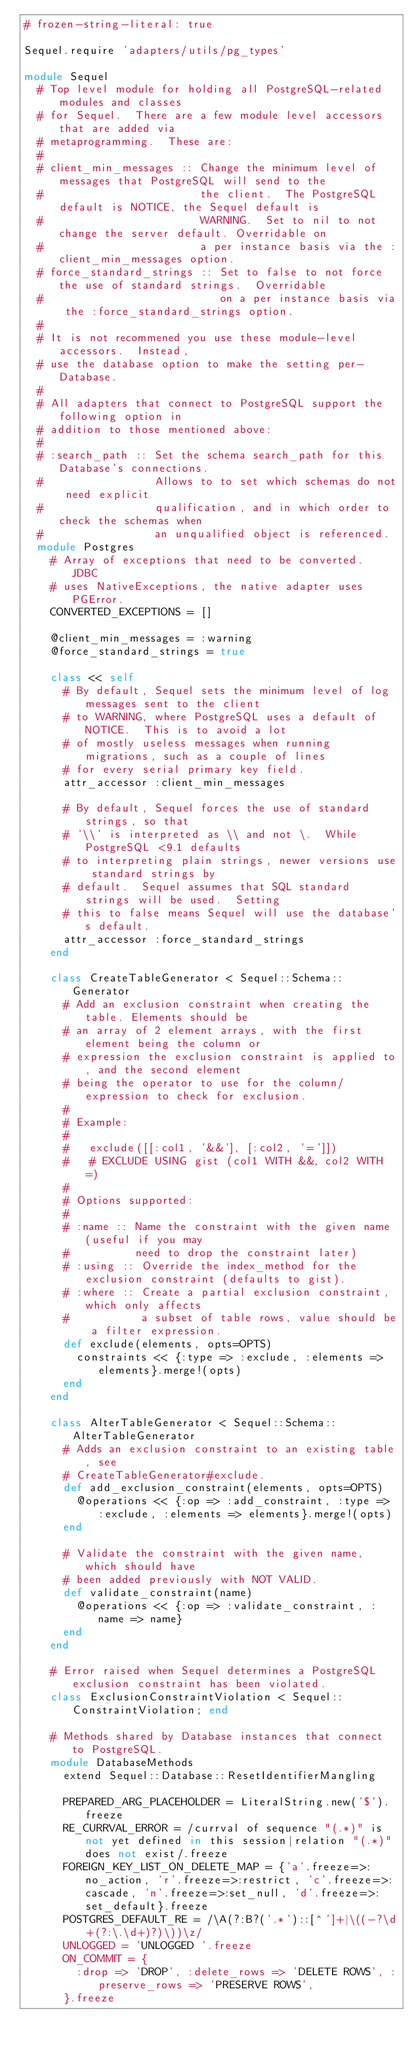Convert code to text. <code><loc_0><loc_0><loc_500><loc_500><_Ruby_># frozen-string-literal: true

Sequel.require 'adapters/utils/pg_types'

module Sequel
  # Top level module for holding all PostgreSQL-related modules and classes
  # for Sequel.  There are a few module level accessors that are added via
  # metaprogramming.  These are:
  #
  # client_min_messages :: Change the minimum level of messages that PostgreSQL will send to the
  #                        the client.  The PostgreSQL default is NOTICE, the Sequel default is
  #                        WARNING.  Set to nil to not change the server default. Overridable on
  #                        a per instance basis via the :client_min_messages option.
  # force_standard_strings :: Set to false to not force the use of standard strings.  Overridable
  #                           on a per instance basis via the :force_standard_strings option.
  #
  # It is not recommened you use these module-level accessors.  Instead,
  # use the database option to make the setting per-Database.
  #
  # All adapters that connect to PostgreSQL support the following option in
  # addition to those mentioned above:
  #
  # :search_path :: Set the schema search_path for this Database's connections.
  #                 Allows to to set which schemas do not need explicit
  #                 qualification, and in which order to check the schemas when
  #                 an unqualified object is referenced.
  module Postgres
    # Array of exceptions that need to be converted.  JDBC
    # uses NativeExceptions, the native adapter uses PGError.
    CONVERTED_EXCEPTIONS = []

    @client_min_messages = :warning
    @force_standard_strings = true

    class << self
      # By default, Sequel sets the minimum level of log messages sent to the client
      # to WARNING, where PostgreSQL uses a default of NOTICE.  This is to avoid a lot
      # of mostly useless messages when running migrations, such as a couple of lines
      # for every serial primary key field.
      attr_accessor :client_min_messages

      # By default, Sequel forces the use of standard strings, so that
      # '\\' is interpreted as \\ and not \.  While PostgreSQL <9.1 defaults
      # to interpreting plain strings, newer versions use standard strings by
      # default.  Sequel assumes that SQL standard strings will be used.  Setting
      # this to false means Sequel will use the database's default.
      attr_accessor :force_standard_strings
    end

    class CreateTableGenerator < Sequel::Schema::Generator
      # Add an exclusion constraint when creating the table. Elements should be
      # an array of 2 element arrays, with the first element being the column or
      # expression the exclusion constraint is applied to, and the second element
      # being the operator to use for the column/expression to check for exclusion.
      #
      # Example:
      #
      #   exclude([[:col1, '&&'], [:col2, '=']])
      #   # EXCLUDE USING gist (col1 WITH &&, col2 WITH =)
      #
      # Options supported:
      #
      # :name :: Name the constraint with the given name (useful if you may
      #          need to drop the constraint later)
      # :using :: Override the index_method for the exclusion constraint (defaults to gist).
      # :where :: Create a partial exclusion constraint, which only affects
      #           a subset of table rows, value should be a filter expression.
      def exclude(elements, opts=OPTS)
        constraints << {:type => :exclude, :elements => elements}.merge!(opts)
      end
    end

    class AlterTableGenerator < Sequel::Schema::AlterTableGenerator
      # Adds an exclusion constraint to an existing table, see
      # CreateTableGenerator#exclude.
      def add_exclusion_constraint(elements, opts=OPTS)
        @operations << {:op => :add_constraint, :type => :exclude, :elements => elements}.merge!(opts)
      end

      # Validate the constraint with the given name, which should have
      # been added previously with NOT VALID.
      def validate_constraint(name)
        @operations << {:op => :validate_constraint, :name => name}
      end
    end

    # Error raised when Sequel determines a PostgreSQL exclusion constraint has been violated.
    class ExclusionConstraintViolation < Sequel::ConstraintViolation; end

    # Methods shared by Database instances that connect to PostgreSQL.
    module DatabaseMethods
      extend Sequel::Database::ResetIdentifierMangling

      PREPARED_ARG_PLACEHOLDER = LiteralString.new('$').freeze
      RE_CURRVAL_ERROR = /currval of sequence "(.*)" is not yet defined in this session|relation "(.*)" does not exist/.freeze
      FOREIGN_KEY_LIST_ON_DELETE_MAP = {'a'.freeze=>:no_action, 'r'.freeze=>:restrict, 'c'.freeze=>:cascade, 'n'.freeze=>:set_null, 'd'.freeze=>:set_default}.freeze
      POSTGRES_DEFAULT_RE = /\A(?:B?('.*')::[^']+|\((-?\d+(?:\.\d+)?)\))\z/
      UNLOGGED = 'UNLOGGED '.freeze
      ON_COMMIT = {
        :drop => 'DROP', :delete_rows => 'DELETE ROWS', :preserve_rows => 'PRESERVE ROWS',
      }.freeze
</code> 